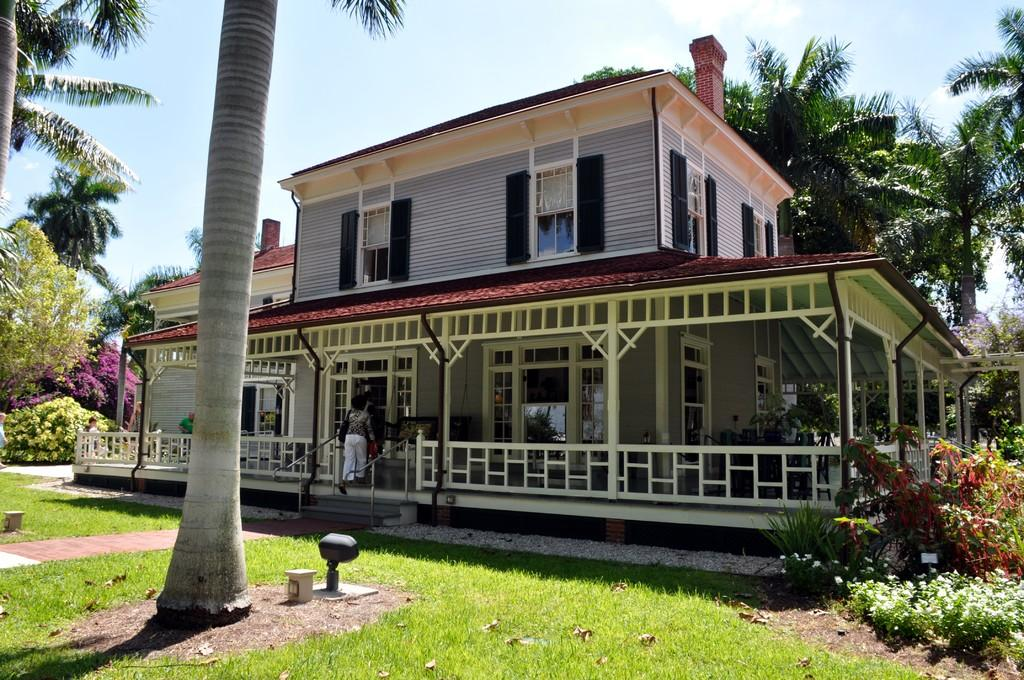What type of structure is visible in the image? There is a building in the image. What natural elements can be seen in the image? There are trees and plants in the image. What activity are the people in the image engaged in? The people in the image are walking. How would you describe the sky in the image? The sky is blue and cloudy in the image. Can you solve the riddle that is written on the blade in the image? There is no riddle or blade present in the image. What phase is the moon in, as depicted in the image? There is no moon present in the image. 